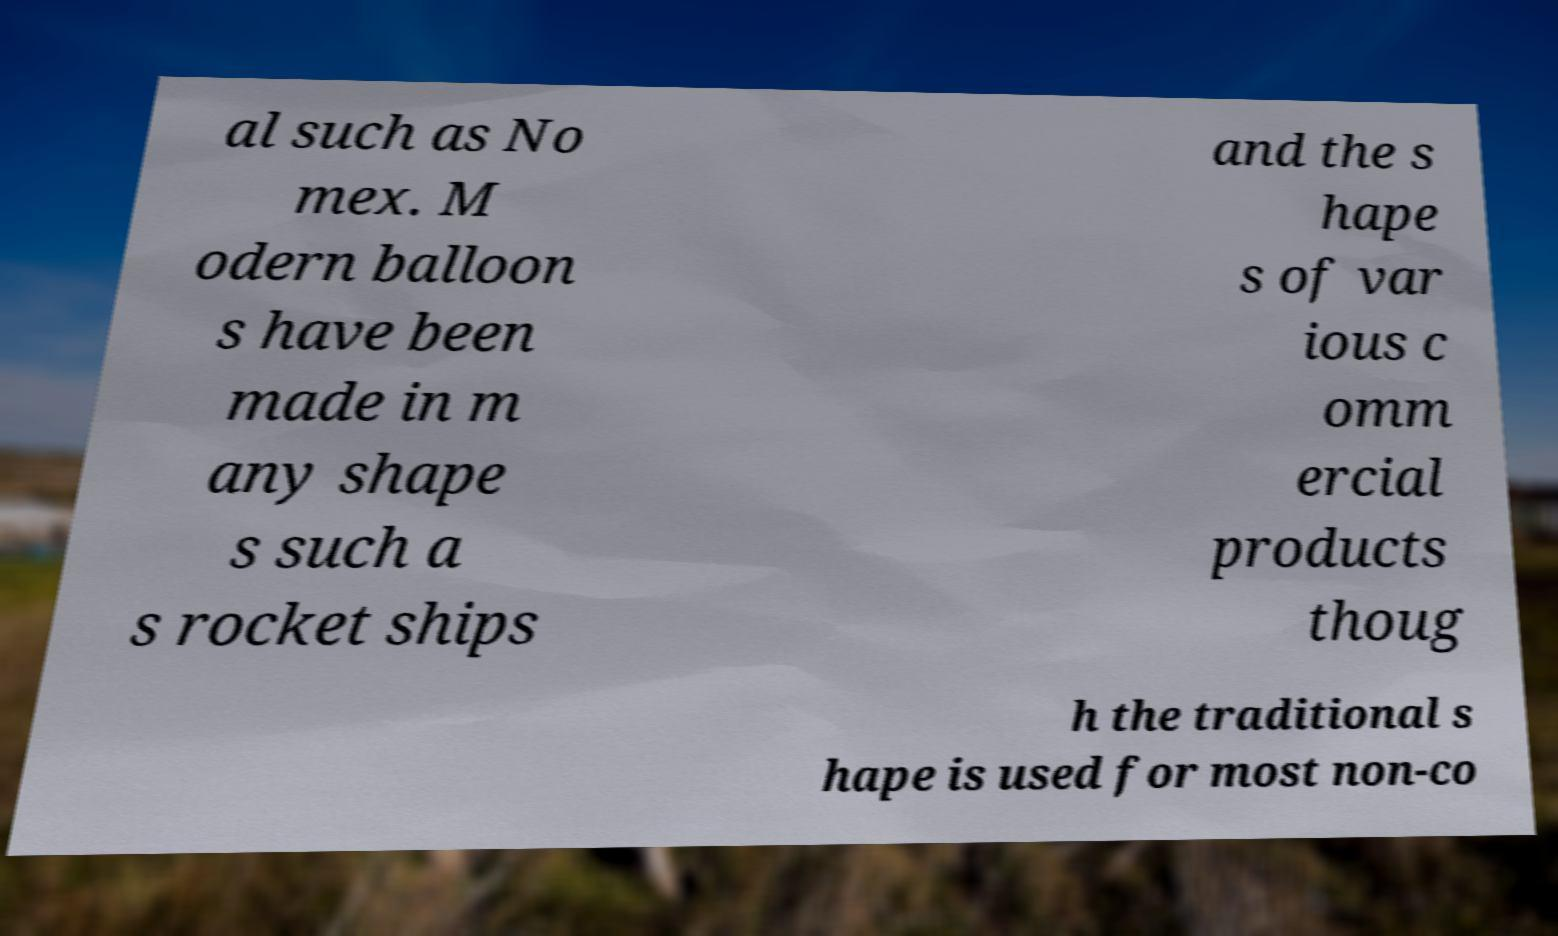Please read and relay the text visible in this image. What does it say? al such as No mex. M odern balloon s have been made in m any shape s such a s rocket ships and the s hape s of var ious c omm ercial products thoug h the traditional s hape is used for most non-co 